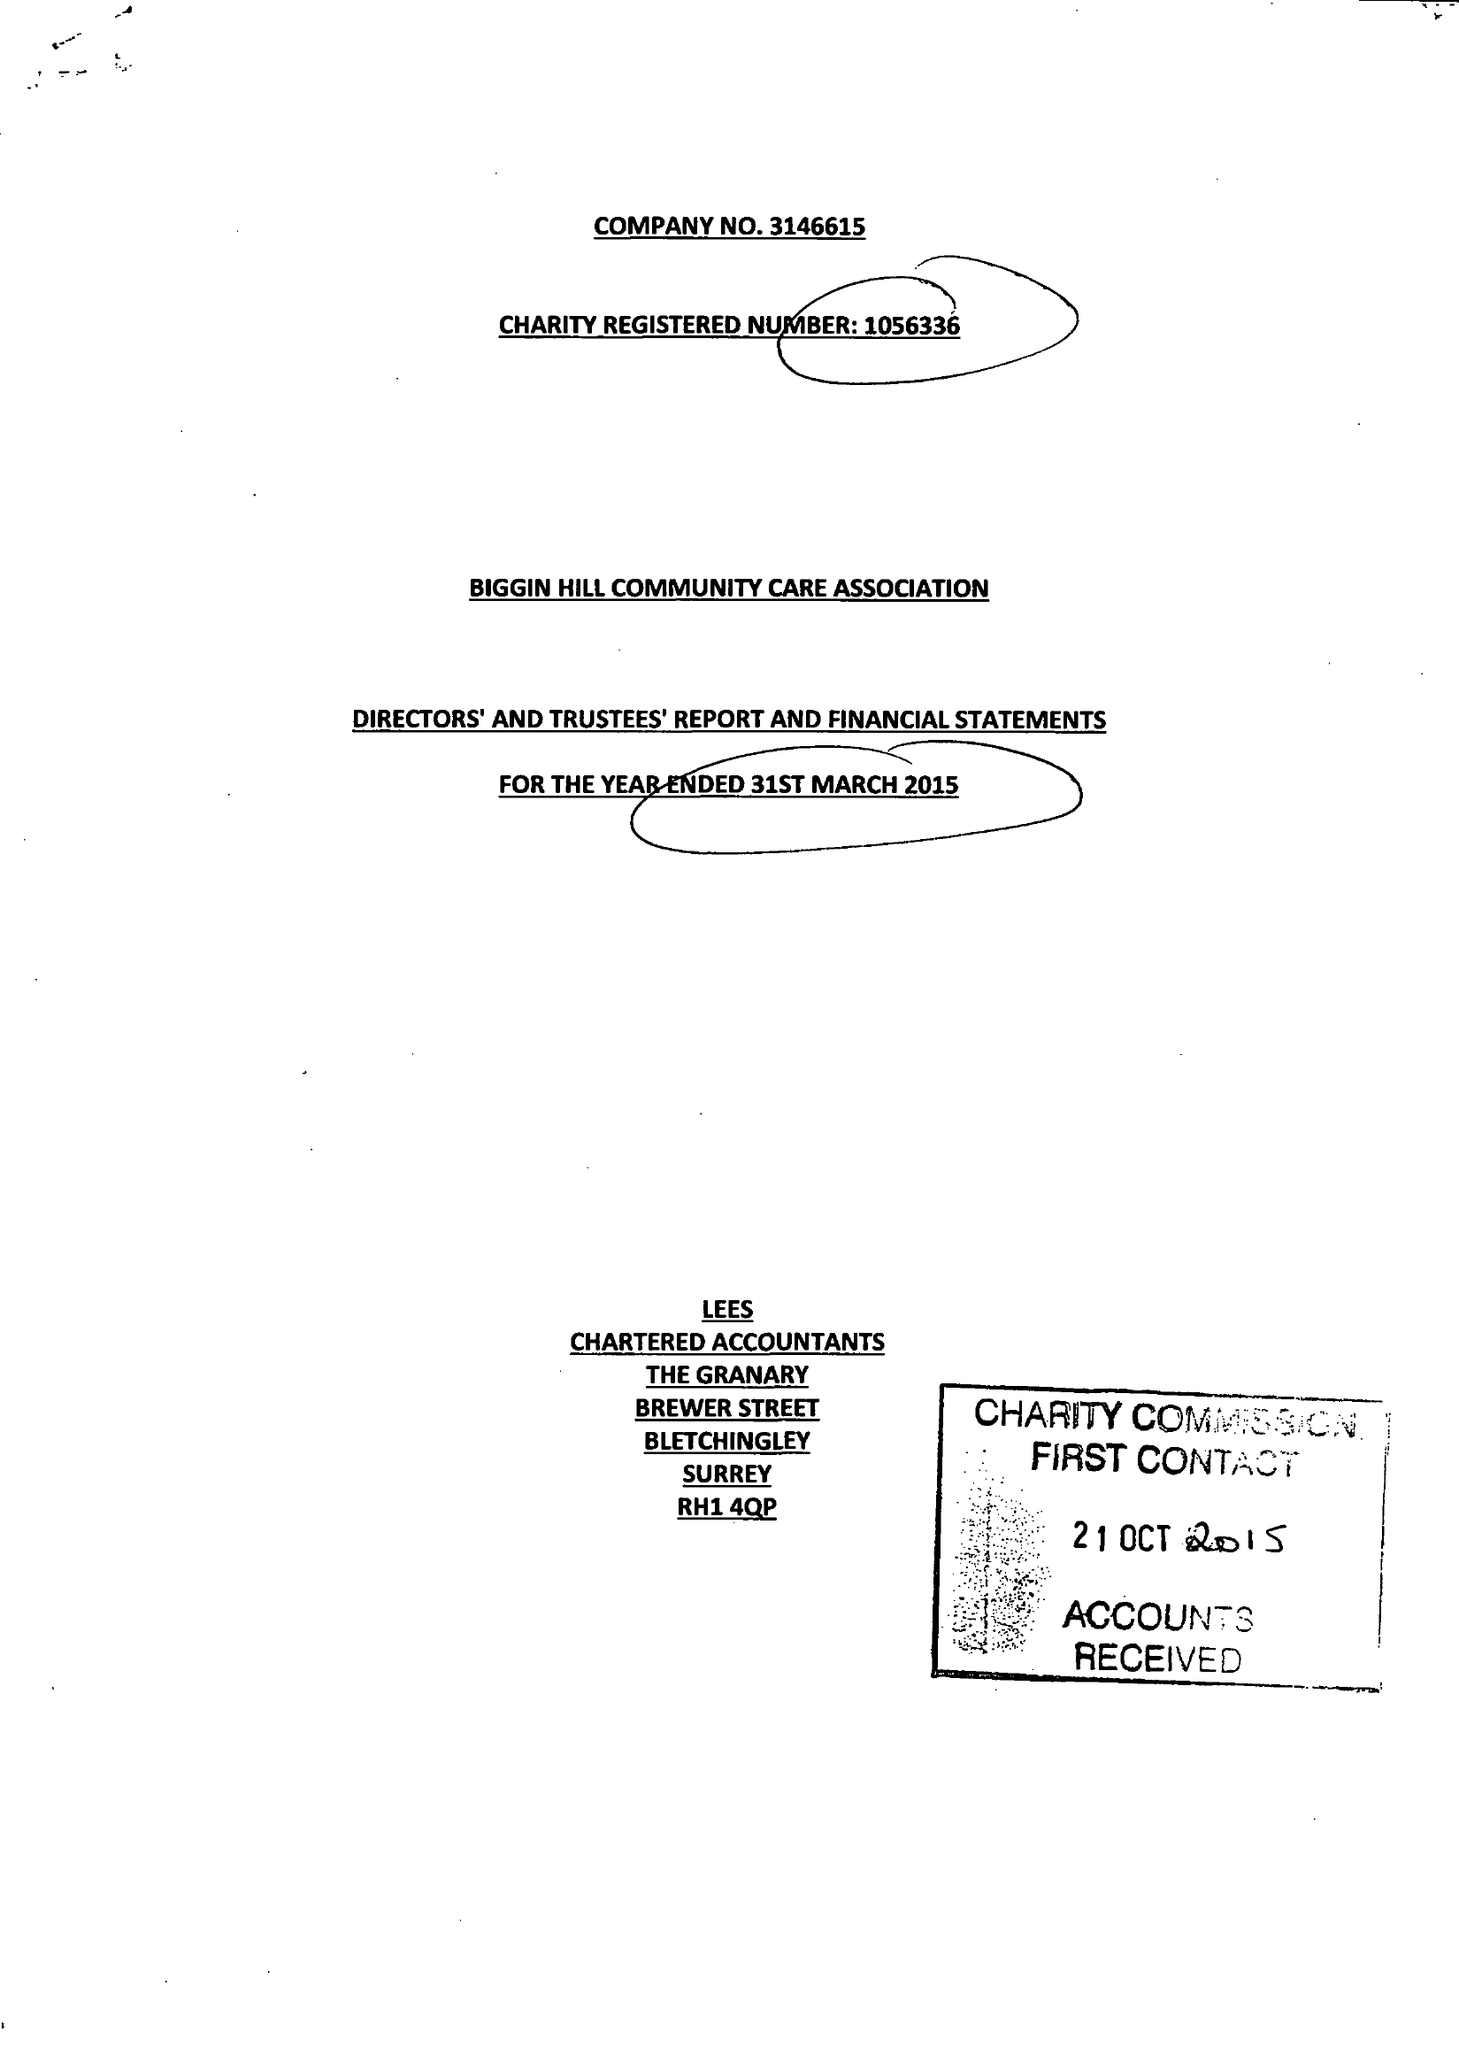What is the value for the spending_annually_in_british_pounds?
Answer the question using a single word or phrase. 75321.00 